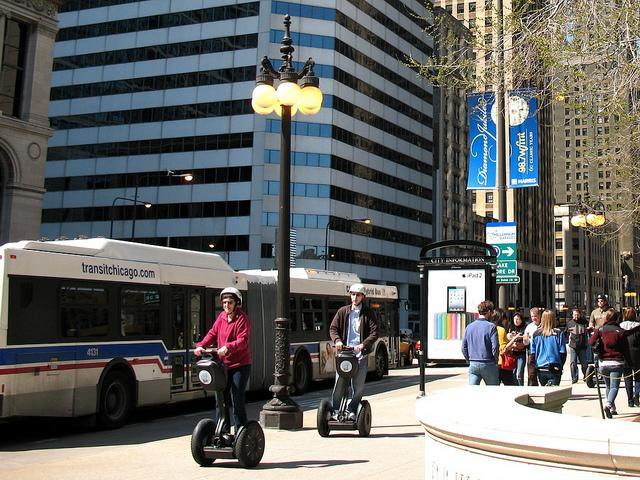Why are the the two riders wearing helmets? Please explain your reasoning. protect heads. The helmets can provide cushioning for their heads so they do not crack. 